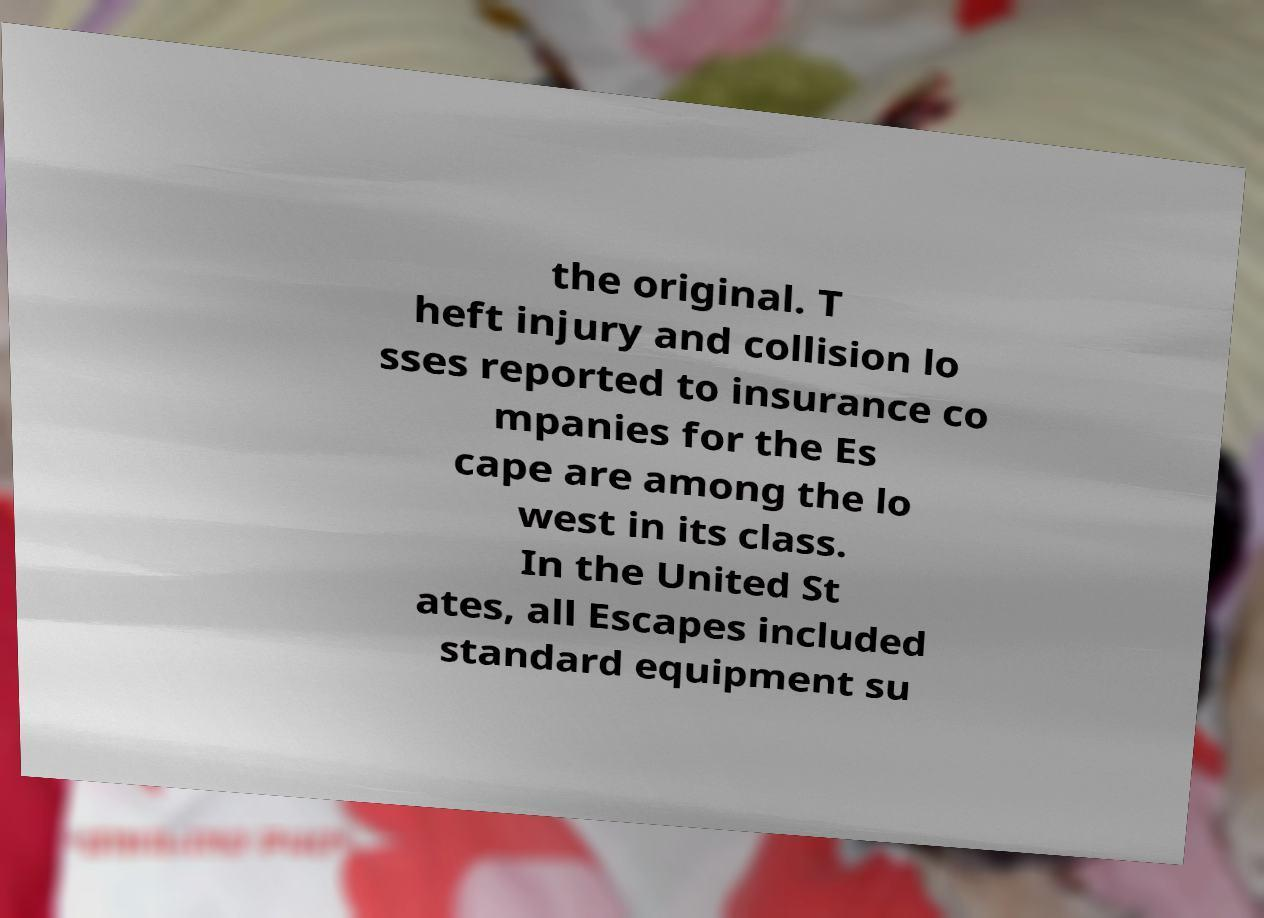Please identify and transcribe the text found in this image. the original. T heft injury and collision lo sses reported to insurance co mpanies for the Es cape are among the lo west in its class. In the United St ates, all Escapes included standard equipment su 